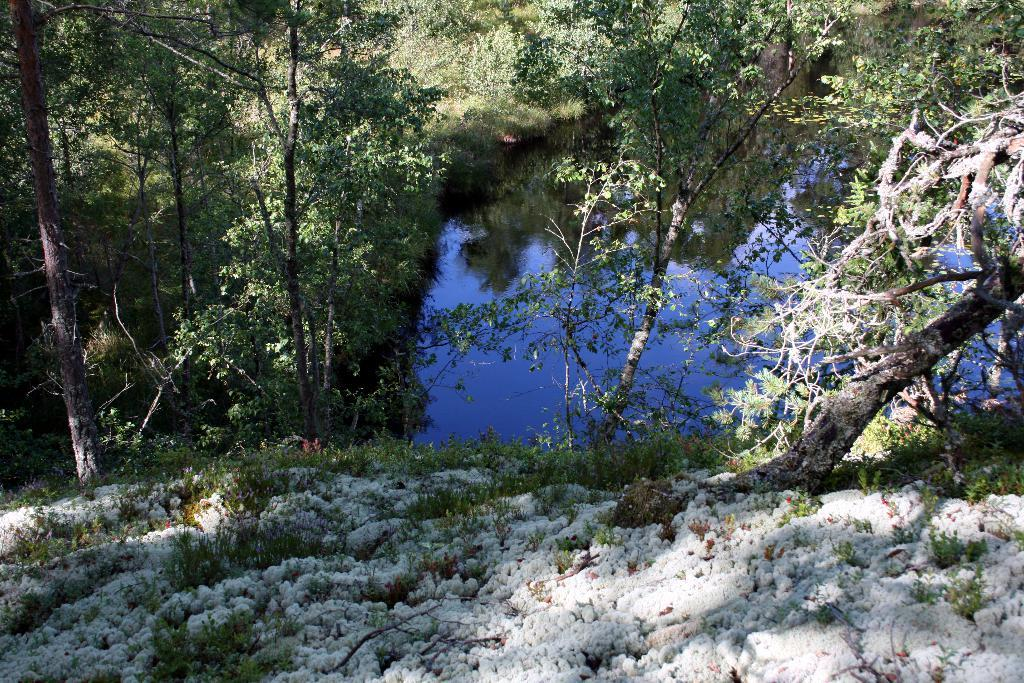What type of vegetation can be seen in the image? There are trees and plants in the image. What natural element is visible in the image? There is water visible in the image. What weather condition is depicted in the image? There is snow in the image. What type of business is being conducted in the image? There is no indication of a business or any commercial activity in the image. What form of art is being performed in the image? There is no art or performance present in the image. 